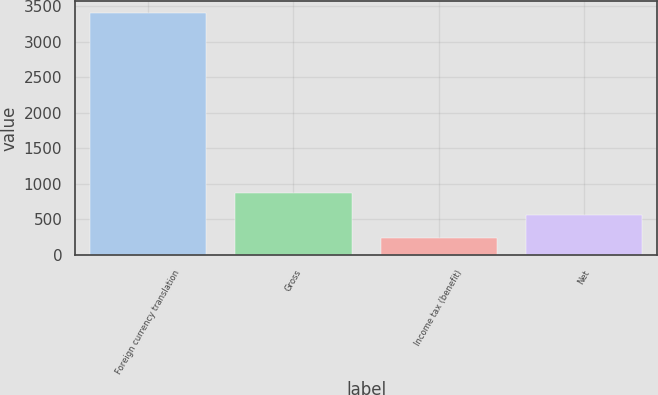<chart> <loc_0><loc_0><loc_500><loc_500><bar_chart><fcel>Foreign currency translation<fcel>Gross<fcel>Income tax (benefit)<fcel>Net<nl><fcel>3402<fcel>874.8<fcel>243<fcel>558.9<nl></chart> 